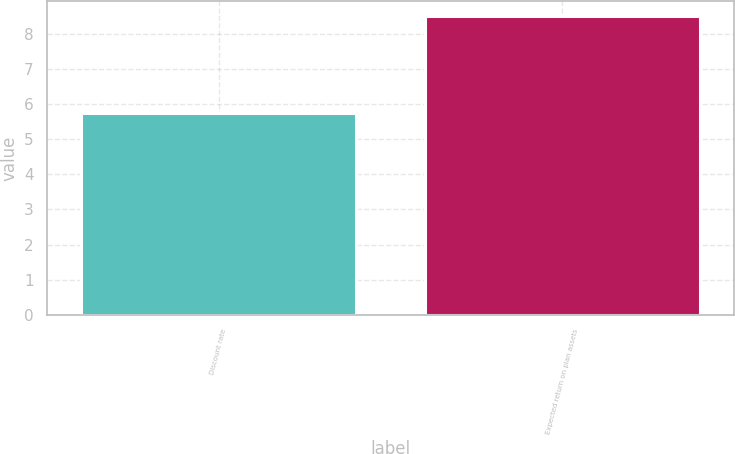<chart> <loc_0><loc_0><loc_500><loc_500><bar_chart><fcel>Discount rate<fcel>Expected return on plan assets<nl><fcel>5.75<fcel>8.5<nl></chart> 